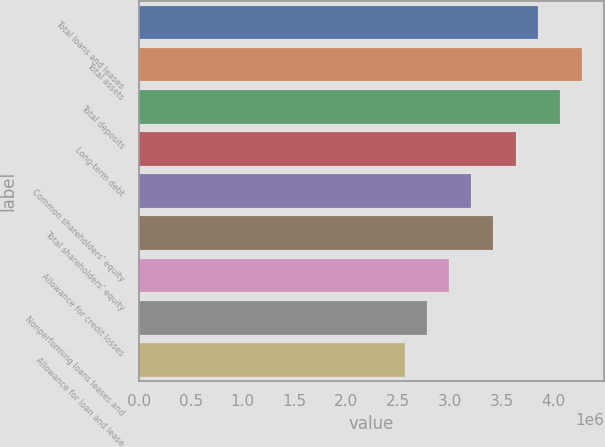<chart> <loc_0><loc_0><loc_500><loc_500><bar_chart><fcel>Total loans and leases<fcel>Total assets<fcel>Total deposits<fcel>Long-term debt<fcel>Common shareholders' equity<fcel>Total shareholders' equity<fcel>Allowance for credit losses<fcel>Nonperforming loans leases and<fcel>Allowance for loan and lease<nl><fcel>3.845e+06<fcel>4.27222e+06<fcel>4.05861e+06<fcel>3.63138e+06<fcel>3.20416e+06<fcel>3.41777e+06<fcel>2.99055e+06<fcel>2.77694e+06<fcel>2.56333e+06<nl></chart> 